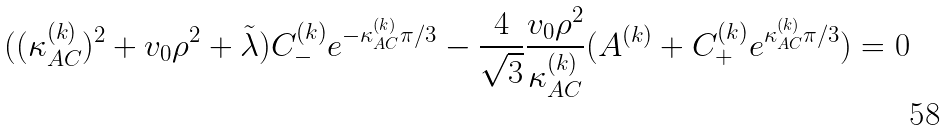Convert formula to latex. <formula><loc_0><loc_0><loc_500><loc_500>( ( \kappa _ { A C } ^ { ( k ) } ) ^ { 2 } + v _ { 0 } \rho ^ { 2 } + \tilde { \lambda } ) C _ { - } ^ { ( k ) } e ^ { - \kappa _ { A C } ^ { ( k ) } \pi / 3 } - \frac { 4 } { \sqrt { 3 } } \frac { v _ { 0 } \rho ^ { 2 } } { \kappa _ { A C } ^ { ( k ) } } ( A ^ { ( k ) } + C _ { + } ^ { ( k ) } e ^ { \kappa _ { A C } ^ { ( k ) } \pi / 3 } ) = 0 \,</formula> 